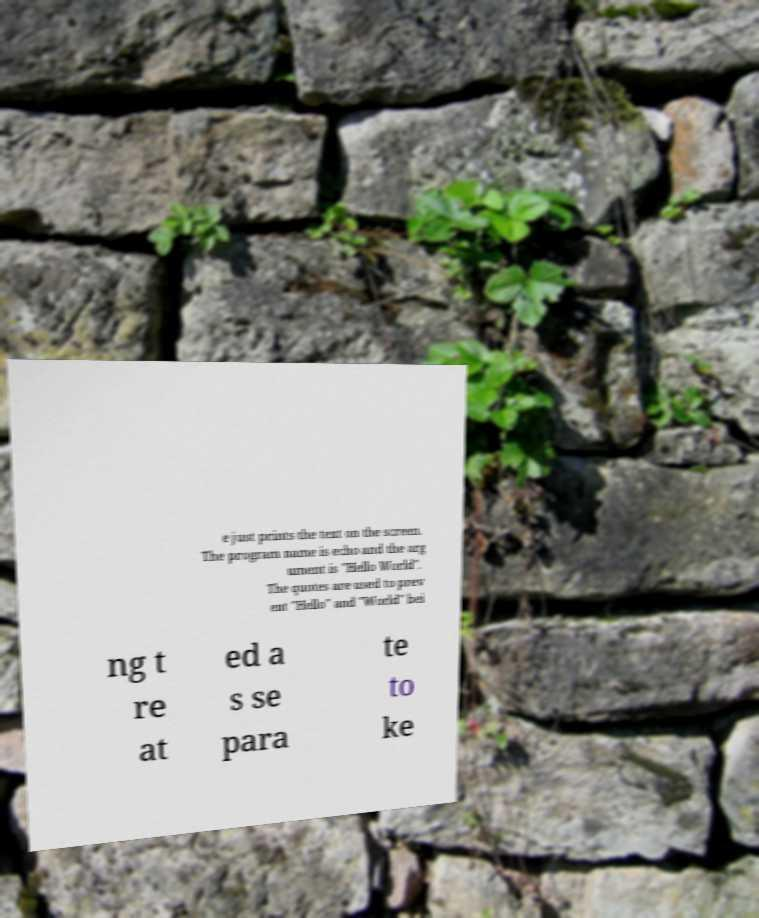Please identify and transcribe the text found in this image. e just prints the text on the screen. The program name is echo and the arg ument is "Hello World". The quotes are used to prev ent "Hello" and "World" bei ng t re at ed a s se para te to ke 